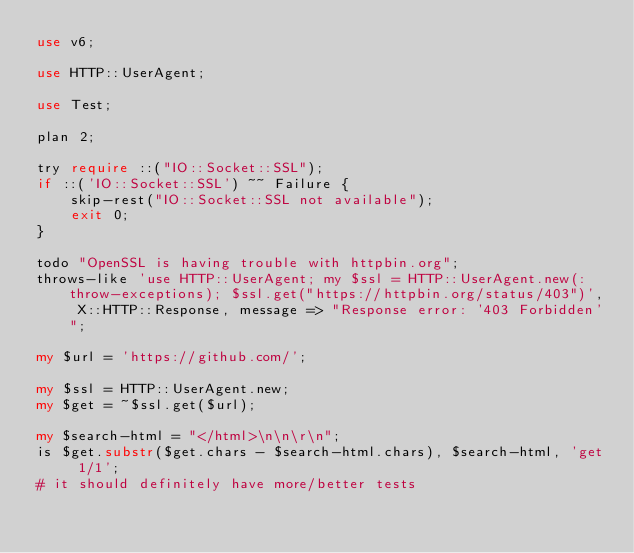Convert code to text. <code><loc_0><loc_0><loc_500><loc_500><_Perl_>use v6;

use HTTP::UserAgent;

use Test;

plan 2;

try require ::("IO::Socket::SSL");
if ::('IO::Socket::SSL') ~~ Failure {
    skip-rest("IO::Socket::SSL not available");
    exit 0;
}

todo "OpenSSL is having trouble with httpbin.org";
throws-like 'use HTTP::UserAgent; my $ssl = HTTP::UserAgent.new(:throw-exceptions); $ssl.get("https://httpbin.org/status/403")', X::HTTP::Response, message => "Response error: '403 Forbidden'";

my $url = 'https://github.com/';

my $ssl = HTTP::UserAgent.new;
my $get = ~$ssl.get($url);

my $search-html = "</html>\n\n\r\n";
is $get.substr($get.chars - $search-html.chars), $search-html, 'get 1/1';
# it should definitely have more/better tests
</code> 